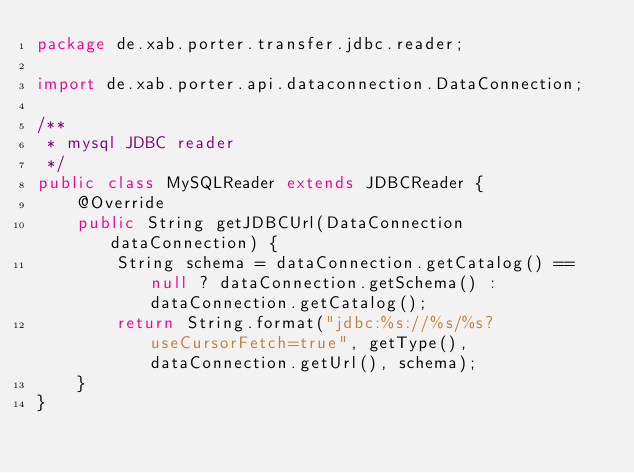<code> <loc_0><loc_0><loc_500><loc_500><_Java_>package de.xab.porter.transfer.jdbc.reader;

import de.xab.porter.api.dataconnection.DataConnection;

/**
 * mysql JDBC reader
 */
public class MySQLReader extends JDBCReader {
    @Override
    public String getJDBCUrl(DataConnection dataConnection) {
        String schema = dataConnection.getCatalog() == null ? dataConnection.getSchema() : dataConnection.getCatalog();
        return String.format("jdbc:%s://%s/%s?useCursorFetch=true", getType(), dataConnection.getUrl(), schema);
    }
}</code> 